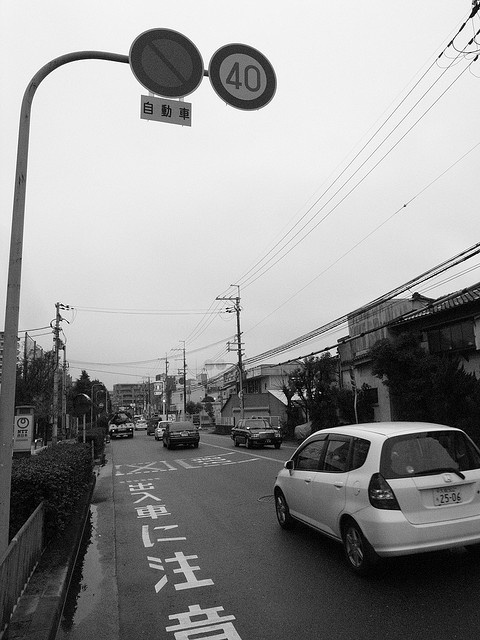Describe the objects in this image and their specific colors. I can see car in white, gray, black, darkgray, and lightgray tones, car in white, black, gray, and lightgray tones, car in white, black, gray, and lightgray tones, truck in white, black, gray, and darkgray tones, and car in white, gray, darkgray, black, and lightgray tones in this image. 